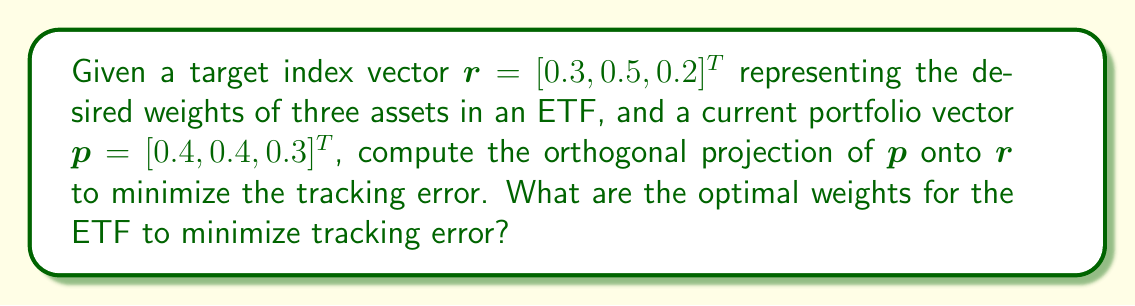Give your solution to this math problem. To minimize the tracking error in an ETF, we need to find the orthogonal projection of the current portfolio vector $\mathbf{p}$ onto the target index vector $\mathbf{r}$. This can be done using the following steps:

1. Calculate the projection matrix $P$:
   $$P = \frac{\mathbf{r}\mathbf{r}^T}{\mathbf{r}^T\mathbf{r}}$$

2. Compute $\mathbf{r}^T\mathbf{r}$:
   $$\mathbf{r}^T\mathbf{r} = 0.3^2 + 0.5^2 + 0.2^2 = 0.38$$

3. Calculate $\mathbf{r}\mathbf{r}^T$:
   $$\mathbf{r}\mathbf{r}^T = \begin{bmatrix}
   0.09 & 0.15 & 0.06 \\
   0.15 & 0.25 & 0.10 \\
   0.06 & 0.10 & 0.04
   \end{bmatrix}$$

4. Compute the projection matrix $P$:
   $$P = \frac{1}{0.38}\begin{bmatrix}
   0.09 & 0.15 & 0.06 \\
   0.15 & 0.25 & 0.10 \\
   0.06 & 0.10 & 0.04
   \end{bmatrix}$$

5. Calculate the orthogonal projection $\mathbf{p}_{\text{proj}}$:
   $$\mathbf{p}_{\text{proj}} = P\mathbf{p}$$

6. Multiply $P$ and $\mathbf{p}$:
   $$\mathbf{p}_{\text{proj}} = \frac{1}{0.38}\begin{bmatrix}
   0.09 & 0.15 & 0.06 \\
   0.15 & 0.25 & 0.10 \\
   0.06 & 0.10 & 0.04
   \end{bmatrix} \begin{bmatrix} 0.4 \\ 0.4 \\ 0.3 \end{bmatrix}$$

7. Perform the matrix multiplication:
   $$\mathbf{p}_{\text{proj}} = \frac{1}{0.38}\begin{bmatrix}
   0.09(0.4) + 0.15(0.4) + 0.06(0.3) \\
   0.15(0.4) + 0.25(0.4) + 0.10(0.3) \\
   0.06(0.4) + 0.10(0.4) + 0.04(0.3)
   \end{bmatrix}$$

8. Simplify:
   $$\mathbf{p}_{\text{proj}} = \frac{1}{0.38}\begin{bmatrix}
   0.114 \\
   0.190 \\
   0.076
   \end{bmatrix}$$

9. Calculate the final result:
   $$\mathbf{p}_{\text{proj}} = \begin{bmatrix}
   0.3 \\
   0.5 \\
   0.2
   \end{bmatrix}$$

The optimal weights for the ETF to minimize tracking error are the components of $\mathbf{p}_{\text{proj}}$.
Answer: $[0.3, 0.5, 0.2]^T$ 